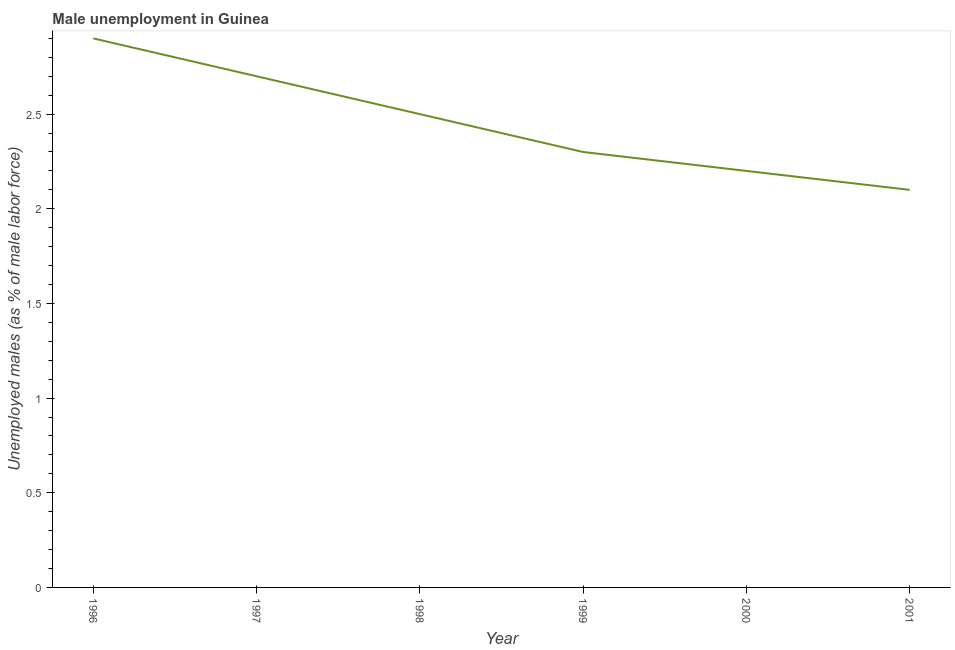What is the unemployed males population in 1996?
Provide a succinct answer. 2.9. Across all years, what is the maximum unemployed males population?
Ensure brevity in your answer.  2.9. Across all years, what is the minimum unemployed males population?
Offer a very short reply. 2.1. What is the sum of the unemployed males population?
Give a very brief answer. 14.7. What is the difference between the unemployed males population in 1998 and 2000?
Offer a terse response. 0.3. What is the average unemployed males population per year?
Give a very brief answer. 2.45. What is the median unemployed males population?
Offer a terse response. 2.4. What is the ratio of the unemployed males population in 1996 to that in 2001?
Your response must be concise. 1.38. Is the unemployed males population in 1996 less than that in 1998?
Give a very brief answer. No. What is the difference between the highest and the second highest unemployed males population?
Provide a succinct answer. 0.2. Is the sum of the unemployed males population in 1997 and 1998 greater than the maximum unemployed males population across all years?
Your answer should be very brief. Yes. What is the difference between the highest and the lowest unemployed males population?
Keep it short and to the point. 0.8. In how many years, is the unemployed males population greater than the average unemployed males population taken over all years?
Give a very brief answer. 3. Does the unemployed males population monotonically increase over the years?
Make the answer very short. No. How many lines are there?
Offer a terse response. 1. How many years are there in the graph?
Provide a succinct answer. 6. What is the difference between two consecutive major ticks on the Y-axis?
Ensure brevity in your answer.  0.5. Does the graph contain grids?
Your answer should be compact. No. What is the title of the graph?
Give a very brief answer. Male unemployment in Guinea. What is the label or title of the X-axis?
Provide a short and direct response. Year. What is the label or title of the Y-axis?
Provide a succinct answer. Unemployed males (as % of male labor force). What is the Unemployed males (as % of male labor force) of 1996?
Ensure brevity in your answer.  2.9. What is the Unemployed males (as % of male labor force) in 1997?
Your answer should be compact. 2.7. What is the Unemployed males (as % of male labor force) of 1999?
Offer a terse response. 2.3. What is the Unemployed males (as % of male labor force) of 2000?
Make the answer very short. 2.2. What is the Unemployed males (as % of male labor force) in 2001?
Your answer should be very brief. 2.1. What is the difference between the Unemployed males (as % of male labor force) in 1996 and 1998?
Your answer should be very brief. 0.4. What is the difference between the Unemployed males (as % of male labor force) in 1996 and 2000?
Your response must be concise. 0.7. What is the difference between the Unemployed males (as % of male labor force) in 1996 and 2001?
Your response must be concise. 0.8. What is the difference between the Unemployed males (as % of male labor force) in 1997 and 1998?
Make the answer very short. 0.2. What is the difference between the Unemployed males (as % of male labor force) in 1997 and 2001?
Give a very brief answer. 0.6. What is the difference between the Unemployed males (as % of male labor force) in 1998 and 1999?
Make the answer very short. 0.2. What is the difference between the Unemployed males (as % of male labor force) in 1998 and 2001?
Your answer should be compact. 0.4. What is the difference between the Unemployed males (as % of male labor force) in 1999 and 2000?
Offer a terse response. 0.1. What is the difference between the Unemployed males (as % of male labor force) in 1999 and 2001?
Your answer should be very brief. 0.2. What is the ratio of the Unemployed males (as % of male labor force) in 1996 to that in 1997?
Make the answer very short. 1.07. What is the ratio of the Unemployed males (as % of male labor force) in 1996 to that in 1998?
Your response must be concise. 1.16. What is the ratio of the Unemployed males (as % of male labor force) in 1996 to that in 1999?
Ensure brevity in your answer.  1.26. What is the ratio of the Unemployed males (as % of male labor force) in 1996 to that in 2000?
Give a very brief answer. 1.32. What is the ratio of the Unemployed males (as % of male labor force) in 1996 to that in 2001?
Keep it short and to the point. 1.38. What is the ratio of the Unemployed males (as % of male labor force) in 1997 to that in 1998?
Ensure brevity in your answer.  1.08. What is the ratio of the Unemployed males (as % of male labor force) in 1997 to that in 1999?
Offer a terse response. 1.17. What is the ratio of the Unemployed males (as % of male labor force) in 1997 to that in 2000?
Your answer should be very brief. 1.23. What is the ratio of the Unemployed males (as % of male labor force) in 1997 to that in 2001?
Your answer should be very brief. 1.29. What is the ratio of the Unemployed males (as % of male labor force) in 1998 to that in 1999?
Provide a short and direct response. 1.09. What is the ratio of the Unemployed males (as % of male labor force) in 1998 to that in 2000?
Your answer should be compact. 1.14. What is the ratio of the Unemployed males (as % of male labor force) in 1998 to that in 2001?
Make the answer very short. 1.19. What is the ratio of the Unemployed males (as % of male labor force) in 1999 to that in 2000?
Give a very brief answer. 1.04. What is the ratio of the Unemployed males (as % of male labor force) in 1999 to that in 2001?
Your response must be concise. 1.09. What is the ratio of the Unemployed males (as % of male labor force) in 2000 to that in 2001?
Give a very brief answer. 1.05. 